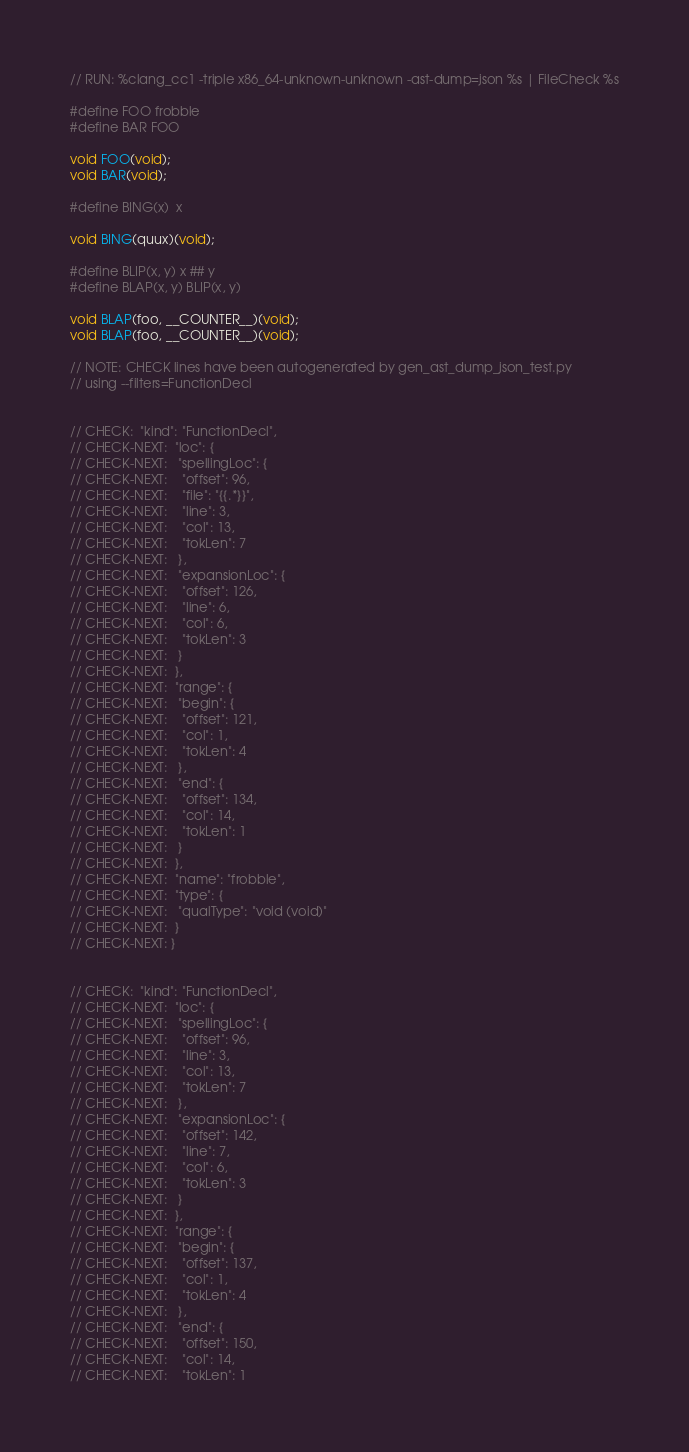<code> <loc_0><loc_0><loc_500><loc_500><_C_>// RUN: %clang_cc1 -triple x86_64-unknown-unknown -ast-dump=json %s | FileCheck %s

#define FOO frobble
#define BAR FOO

void FOO(void);
void BAR(void);

#define BING(x)	x

void BING(quux)(void);

#define BLIP(x, y) x ## y
#define BLAP(x, y) BLIP(x, y)

void BLAP(foo, __COUNTER__)(void);
void BLAP(foo, __COUNTER__)(void);

// NOTE: CHECK lines have been autogenerated by gen_ast_dump_json_test.py
// using --filters=FunctionDecl


// CHECK:  "kind": "FunctionDecl",
// CHECK-NEXT:  "loc": {
// CHECK-NEXT:   "spellingLoc": {
// CHECK-NEXT:    "offset": 96,
// CHECK-NEXT:    "file": "{{.*}}",
// CHECK-NEXT:    "line": 3,
// CHECK-NEXT:    "col": 13,
// CHECK-NEXT:    "tokLen": 7
// CHECK-NEXT:   },
// CHECK-NEXT:   "expansionLoc": {
// CHECK-NEXT:    "offset": 126,
// CHECK-NEXT:    "line": 6,
// CHECK-NEXT:    "col": 6,
// CHECK-NEXT:    "tokLen": 3
// CHECK-NEXT:   }
// CHECK-NEXT:  },
// CHECK-NEXT:  "range": {
// CHECK-NEXT:   "begin": {
// CHECK-NEXT:    "offset": 121,
// CHECK-NEXT:    "col": 1,
// CHECK-NEXT:    "tokLen": 4
// CHECK-NEXT:   },
// CHECK-NEXT:   "end": {
// CHECK-NEXT:    "offset": 134,
// CHECK-NEXT:    "col": 14,
// CHECK-NEXT:    "tokLen": 1
// CHECK-NEXT:   }
// CHECK-NEXT:  },
// CHECK-NEXT:  "name": "frobble",
// CHECK-NEXT:  "type": {
// CHECK-NEXT:   "qualType": "void (void)"
// CHECK-NEXT:  }
// CHECK-NEXT: }


// CHECK:  "kind": "FunctionDecl",
// CHECK-NEXT:  "loc": {
// CHECK-NEXT:   "spellingLoc": {
// CHECK-NEXT:    "offset": 96,
// CHECK-NEXT:    "line": 3,
// CHECK-NEXT:    "col": 13,
// CHECK-NEXT:    "tokLen": 7
// CHECK-NEXT:   },
// CHECK-NEXT:   "expansionLoc": {
// CHECK-NEXT:    "offset": 142,
// CHECK-NEXT:    "line": 7,
// CHECK-NEXT:    "col": 6,
// CHECK-NEXT:    "tokLen": 3
// CHECK-NEXT:   }
// CHECK-NEXT:  },
// CHECK-NEXT:  "range": {
// CHECK-NEXT:   "begin": {
// CHECK-NEXT:    "offset": 137,
// CHECK-NEXT:    "col": 1,
// CHECK-NEXT:    "tokLen": 4
// CHECK-NEXT:   },
// CHECK-NEXT:   "end": {
// CHECK-NEXT:    "offset": 150,
// CHECK-NEXT:    "col": 14,
// CHECK-NEXT:    "tokLen": 1</code> 